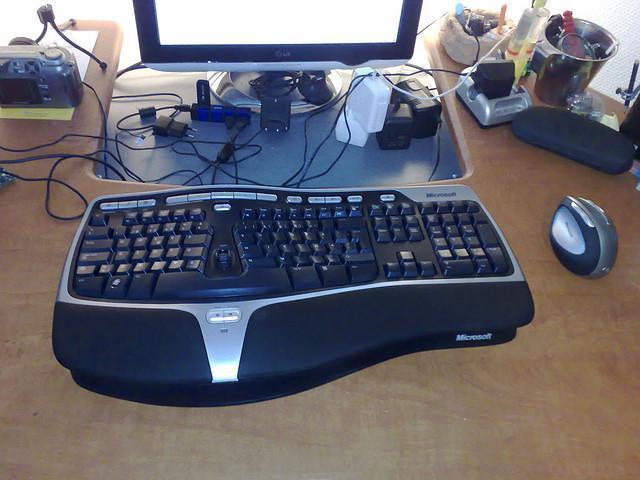How many people are in the picture?
Give a very brief answer. 0. 